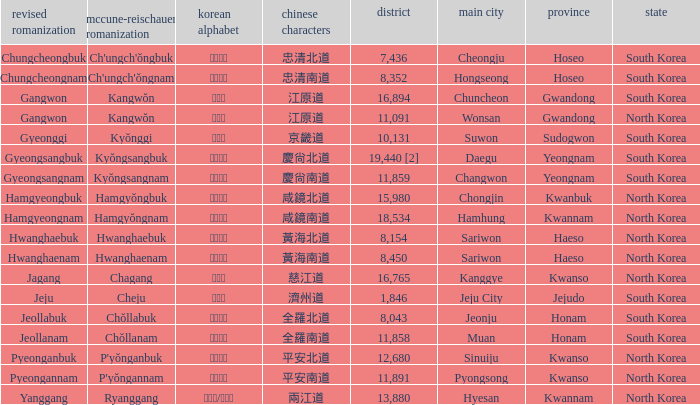What is the area for the province having Hangul of 경기도? 10131.0. 